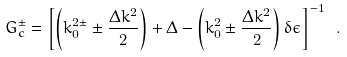<formula> <loc_0><loc_0><loc_500><loc_500>G _ { c } ^ { \pm } = \left [ \left ( k _ { 0 } ^ { 2 \pm } \pm \frac { \Delta k ^ { 2 } } { 2 } \right ) + \Delta - \left ( k _ { 0 } ^ { 2 } \pm \frac { \Delta k ^ { 2 } } { 2 } \right ) \delta \epsilon \right ] ^ { - 1 } \ .</formula> 